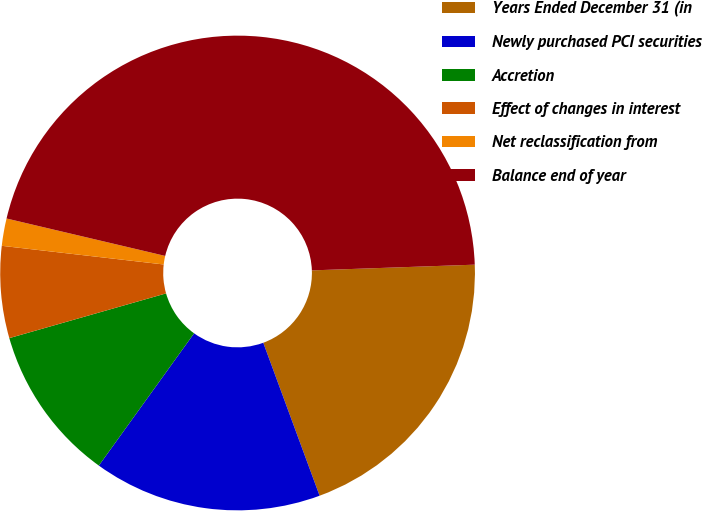<chart> <loc_0><loc_0><loc_500><loc_500><pie_chart><fcel>Years Ended December 31 (in<fcel>Newly purchased PCI securities<fcel>Accretion<fcel>Effect of changes in interest<fcel>Net reclassification from<fcel>Balance end of year<nl><fcel>19.94%<fcel>15.55%<fcel>10.64%<fcel>6.25%<fcel>1.86%<fcel>45.75%<nl></chart> 